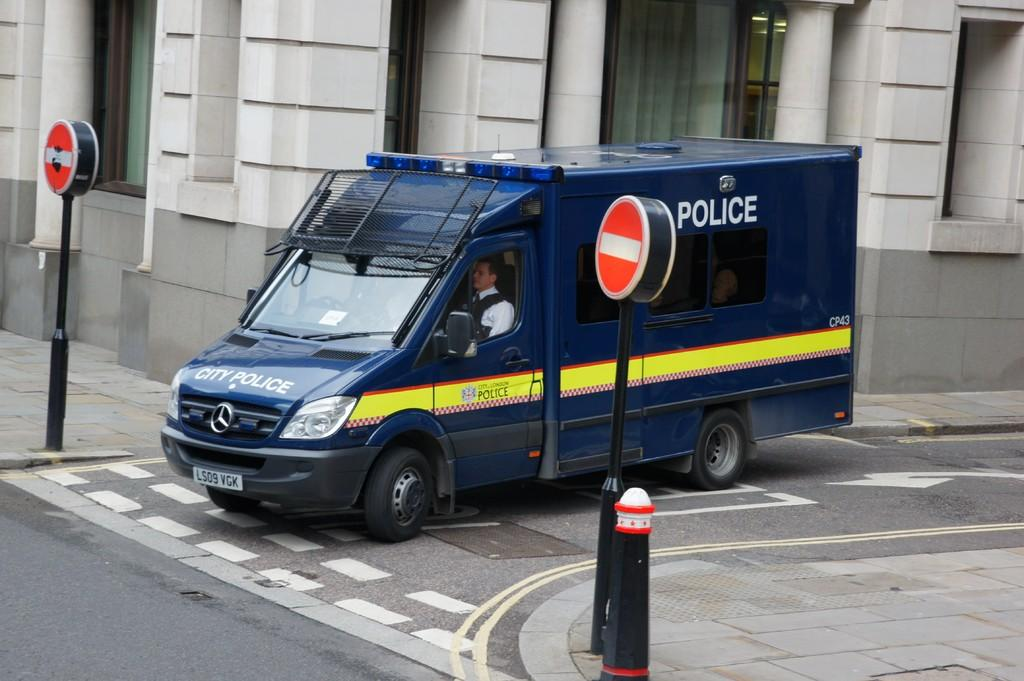<image>
Offer a succinct explanation of the picture presented. The blue and yellow van belongs to the London city police. 